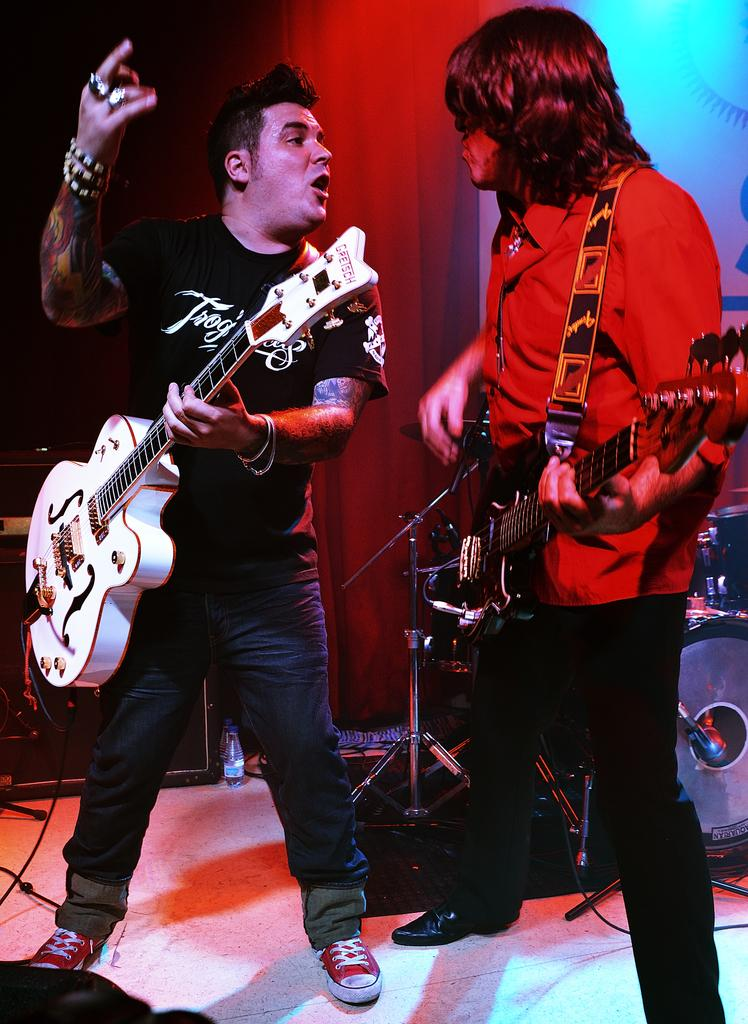How many people are in the image? There are two persons in the image. What are the two persons doing? The two persons are standing and holding guitars. Are there any musical instruments visible in the image? Yes, there are musical instruments in the background of the image. What type of crack is visible on the guitar in the image? There is no crack visible on the guitar in the image. What kind of cabbage is being used as a prop in the image? There is no cabbage present in the image. 